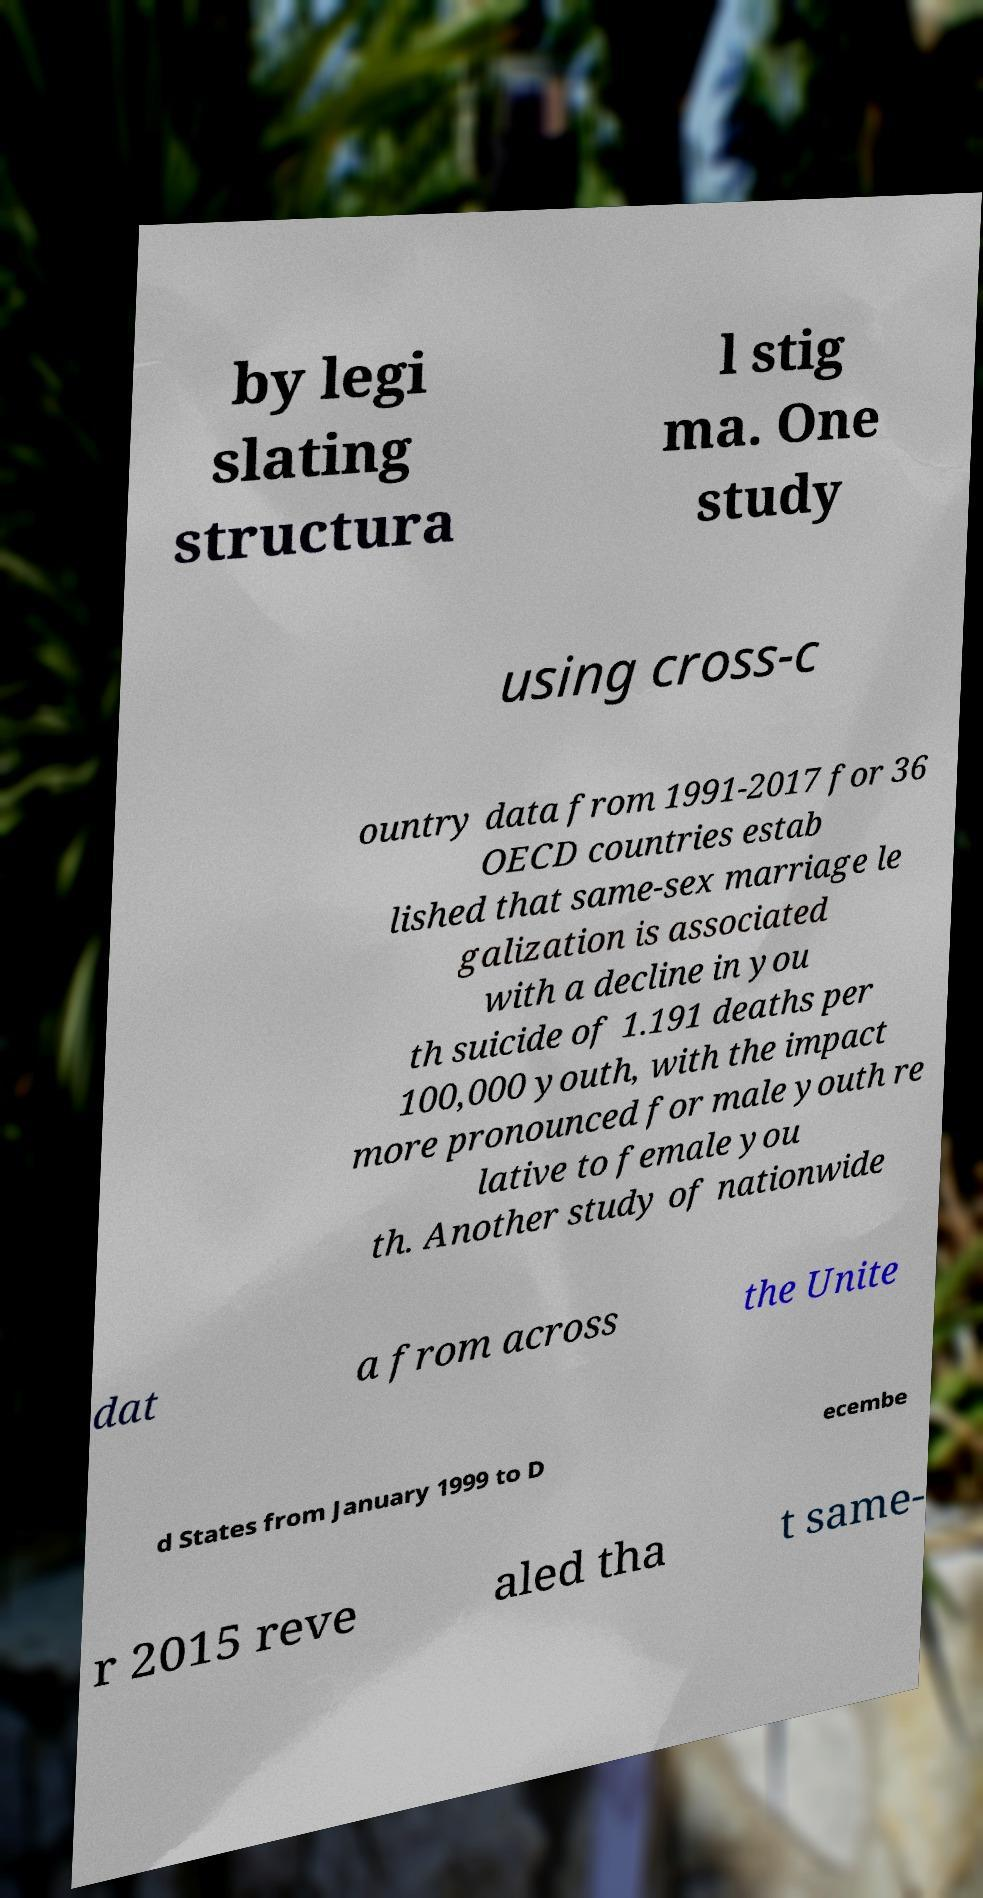There's text embedded in this image that I need extracted. Can you transcribe it verbatim? by legi slating structura l stig ma. One study using cross-c ountry data from 1991-2017 for 36 OECD countries estab lished that same-sex marriage le galization is associated with a decline in you th suicide of 1.191 deaths per 100,000 youth, with the impact more pronounced for male youth re lative to female you th. Another study of nationwide dat a from across the Unite d States from January 1999 to D ecembe r 2015 reve aled tha t same- 